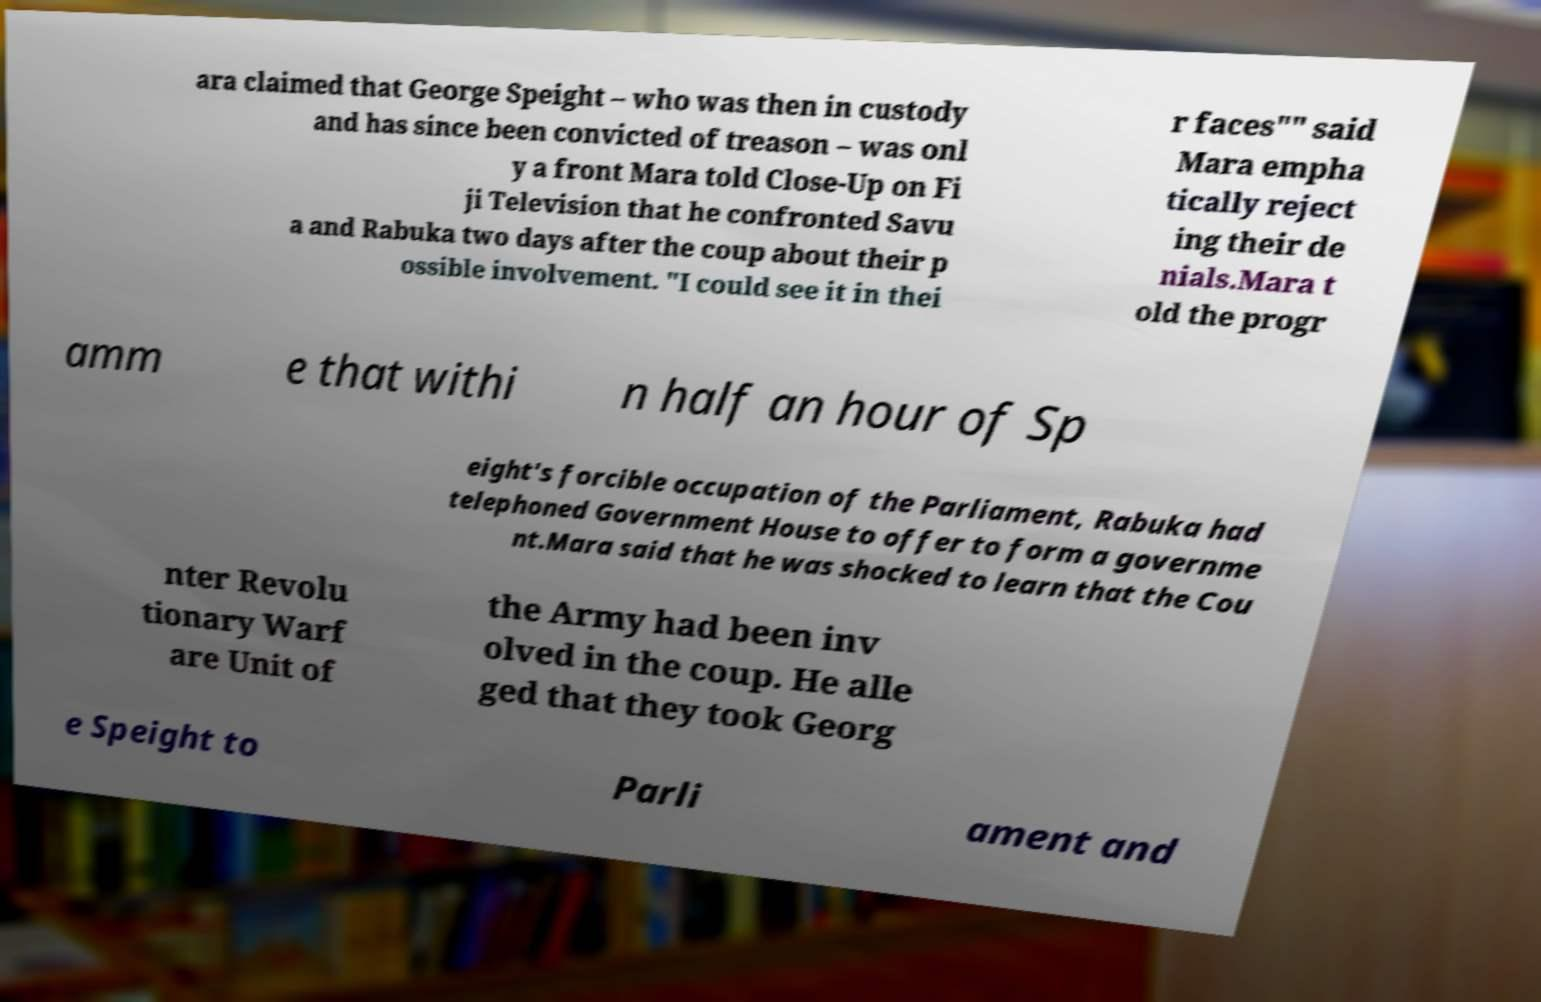Please read and relay the text visible in this image. What does it say? ara claimed that George Speight – who was then in custody and has since been convicted of treason – was onl y a front Mara told Close-Up on Fi ji Television that he confronted Savu a and Rabuka two days after the coup about their p ossible involvement. "I could see it in thei r faces"" said Mara empha tically reject ing their de nials.Mara t old the progr amm e that withi n half an hour of Sp eight's forcible occupation of the Parliament, Rabuka had telephoned Government House to offer to form a governme nt.Mara said that he was shocked to learn that the Cou nter Revolu tionary Warf are Unit of the Army had been inv olved in the coup. He alle ged that they took Georg e Speight to Parli ament and 